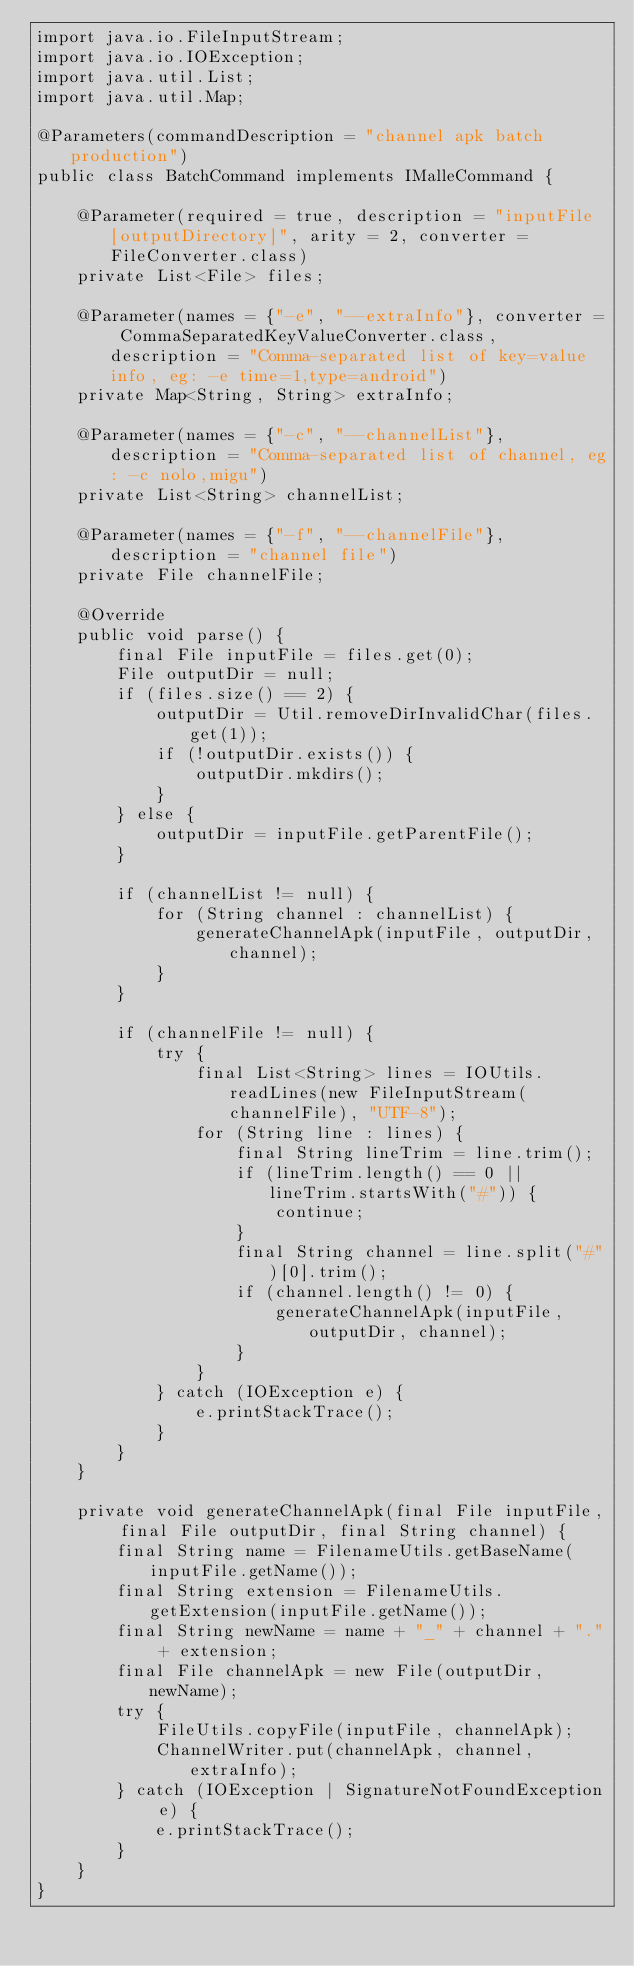<code> <loc_0><loc_0><loc_500><loc_500><_Java_>import java.io.FileInputStream;
import java.io.IOException;
import java.util.List;
import java.util.Map;

@Parameters(commandDescription = "channel apk batch production")
public class BatchCommand implements IMalleCommand {

    @Parameter(required = true, description = "inputFile [outputDirectory]", arity = 2, converter = FileConverter.class)
    private List<File> files;

    @Parameter(names = {"-e", "--extraInfo"}, converter = CommaSeparatedKeyValueConverter.class, description = "Comma-separated list of key=value info, eg: -e time=1,type=android")
    private Map<String, String> extraInfo;

    @Parameter(names = {"-c", "--channelList"}, description = "Comma-separated list of channel, eg: -c nolo,migu")
    private List<String> channelList;

    @Parameter(names = {"-f", "--channelFile"}, description = "channel file")
    private File channelFile;

    @Override
    public void parse() {
        final File inputFile = files.get(0);
        File outputDir = null;
        if (files.size() == 2) {
            outputDir = Util.removeDirInvalidChar(files.get(1));
            if (!outputDir.exists()) {
                outputDir.mkdirs();
            }
        } else {
            outputDir = inputFile.getParentFile();
        }

        if (channelList != null) {
            for (String channel : channelList) {
                generateChannelApk(inputFile, outputDir, channel);
            }
        }

        if (channelFile != null) {
            try {
                final List<String> lines = IOUtils.readLines(new FileInputStream(channelFile), "UTF-8");
                for (String line : lines) {
                    final String lineTrim = line.trim();
                    if (lineTrim.length() == 0 || lineTrim.startsWith("#")) {
                        continue;
                    }
                    final String channel = line.split("#")[0].trim();
                    if (channel.length() != 0) {
                        generateChannelApk(inputFile, outputDir, channel);
                    }
                }
            } catch (IOException e) {
                e.printStackTrace();
            }
        }
    }

    private void generateChannelApk(final File inputFile, final File outputDir, final String channel) {
        final String name = FilenameUtils.getBaseName(inputFile.getName());
        final String extension = FilenameUtils.getExtension(inputFile.getName());
        final String newName = name + "_" + channel + "." + extension;
        final File channelApk = new File(outputDir, newName);
        try {
            FileUtils.copyFile(inputFile, channelApk);
            ChannelWriter.put(channelApk, channel, extraInfo);
        } catch (IOException | SignatureNotFoundException e) {
            e.printStackTrace();
        }
    }
}
</code> 